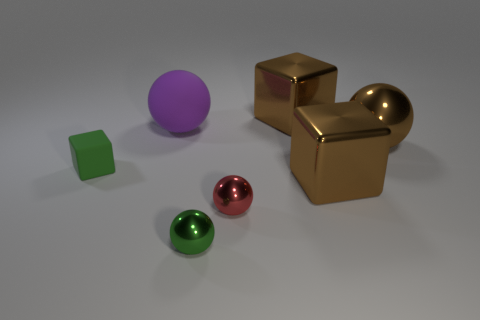Is there anything else that is the same color as the tiny matte block?
Offer a very short reply. Yes. There is a big metal thing that is in front of the large ball right of the red object; what is its color?
Offer a terse response. Brown. Is there a large brown cube?
Provide a succinct answer. Yes. There is a block that is on the right side of the tiny green block and in front of the big brown ball; what is its color?
Make the answer very short. Brown. Does the sphere that is to the left of the green ball have the same size as the green rubber block that is behind the tiny green shiny thing?
Your answer should be compact. No. How many other objects are there of the same size as the green metal ball?
Provide a short and direct response. 2. What number of tiny green shiny things are in front of the big sphere to the left of the green sphere?
Ensure brevity in your answer.  1. Is the number of tiny green things behind the large purple matte sphere less than the number of large rubber spheres?
Provide a short and direct response. Yes. What shape is the small green thing that is behind the tiny green object that is right of the green object to the left of the large rubber sphere?
Provide a succinct answer. Cube. Is the big purple object the same shape as the tiny red thing?
Offer a terse response. Yes. 